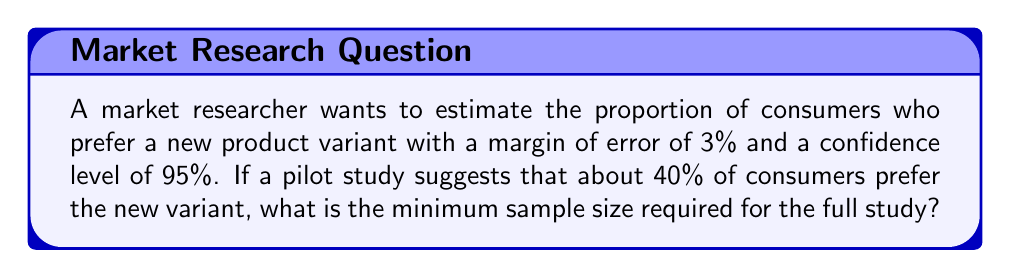Can you solve this math problem? To determine the minimum sample size for this market research study, we'll use the formula for sample size calculation when estimating a proportion:

$$n = \frac{z^2 \cdot p(1-p)}{e^2}$$

Where:
$n$ = sample size
$z$ = z-score for the desired confidence level
$p$ = estimated proportion
$e$ = margin of error

Step 1: Determine the z-score for a 95% confidence level.
For 95% confidence, $z = 1.96$

Step 2: Use the given information.
$p = 0.40$ (40% prefer the new variant)
$e = 0.03$ (3% margin of error)

Step 3: Plug the values into the formula.

$$n = \frac{1.96^2 \cdot 0.40(1-0.40)}{0.03^2}$$

Step 4: Calculate the result.

$$n = \frac{3.8416 \cdot 0.40 \cdot 0.60}{0.0009}$$
$$n = \frac{0.921984}{0.0009}$$
$$n = 1024.42$$

Step 5: Round up to the nearest whole number, as we can't survey a fraction of a person.

The minimum sample size required is 1025 consumers.
Answer: 1025 consumers 